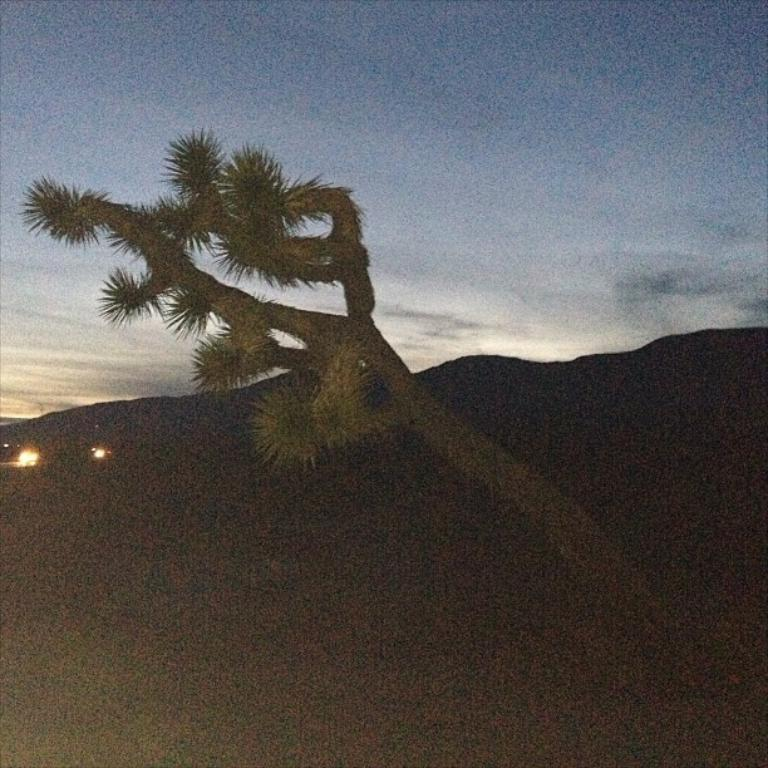What can be seen in the sky in the image? The sky is visible in the image, and clouds are present. What type of natural formation is visible in the image? There are hills in the image. What artificial light sources can be seen in the image? Lights are visible in the image. How many trees are present in the image? There is one tree in the image. Are there any other objects visible in the image besides the ones mentioned? Yes, there are a few other objects in the image. What type of calendar is hanging on the tree in the image? There is no calendar present in the image; it only features a tree and other objects. What type of pencil can be seen being used to draw the hills in the image? There is no pencil or drawing activity depicted in the image; it only shows the hills as they are. 